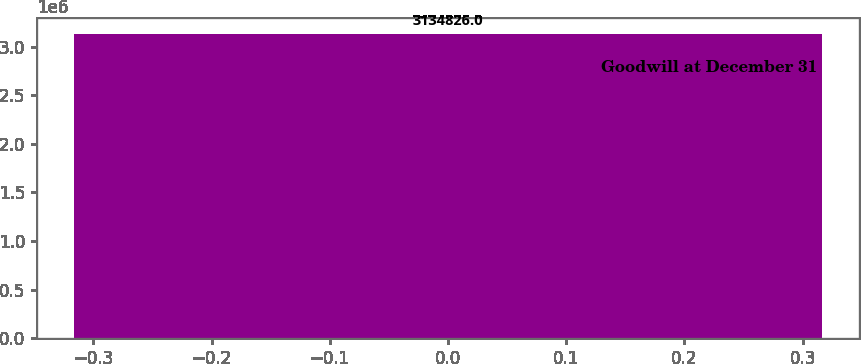Convert chart. <chart><loc_0><loc_0><loc_500><loc_500><bar_chart><fcel>Goodwill at December 31<nl><fcel>3.13483e+06<nl></chart> 